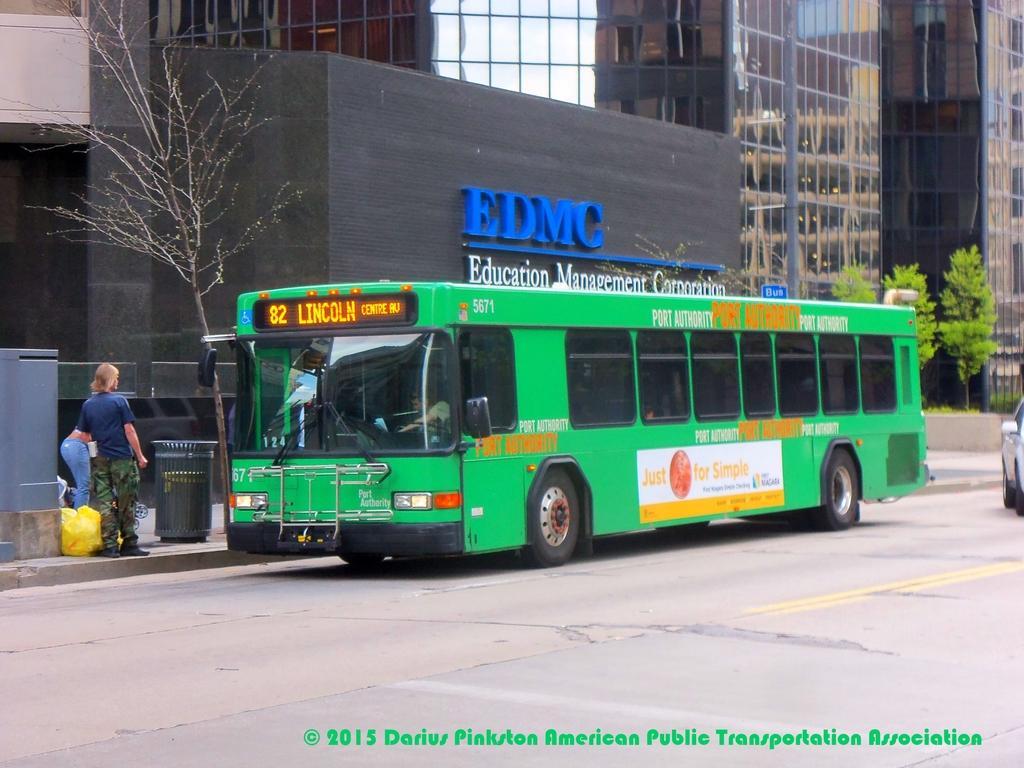How would you summarize this image in a sentence or two? In this image, I can see a bus, which is on the road. I think this is the dustbin. I can see two people standing. This is a tree with branches. I can see the buildings with the glass doors. This looks like a name board, which is attached to the wall. These are the trees. I can see the car on the road. This is the watermark on the image. 